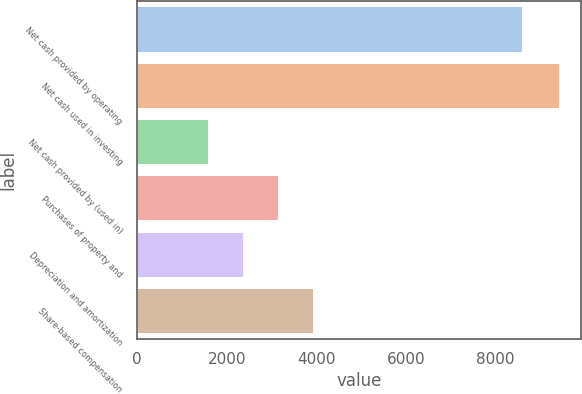<chart> <loc_0><loc_0><loc_500><loc_500><bar_chart><fcel>Net cash provided by operating<fcel>Net cash used in investing<fcel>Net cash provided by (used in)<fcel>Purchases of property and<fcel>Depreciation and amortization<fcel>Share-based compensation<nl><fcel>8599<fcel>9434<fcel>1582<fcel>3152.4<fcel>2367.2<fcel>3937.6<nl></chart> 